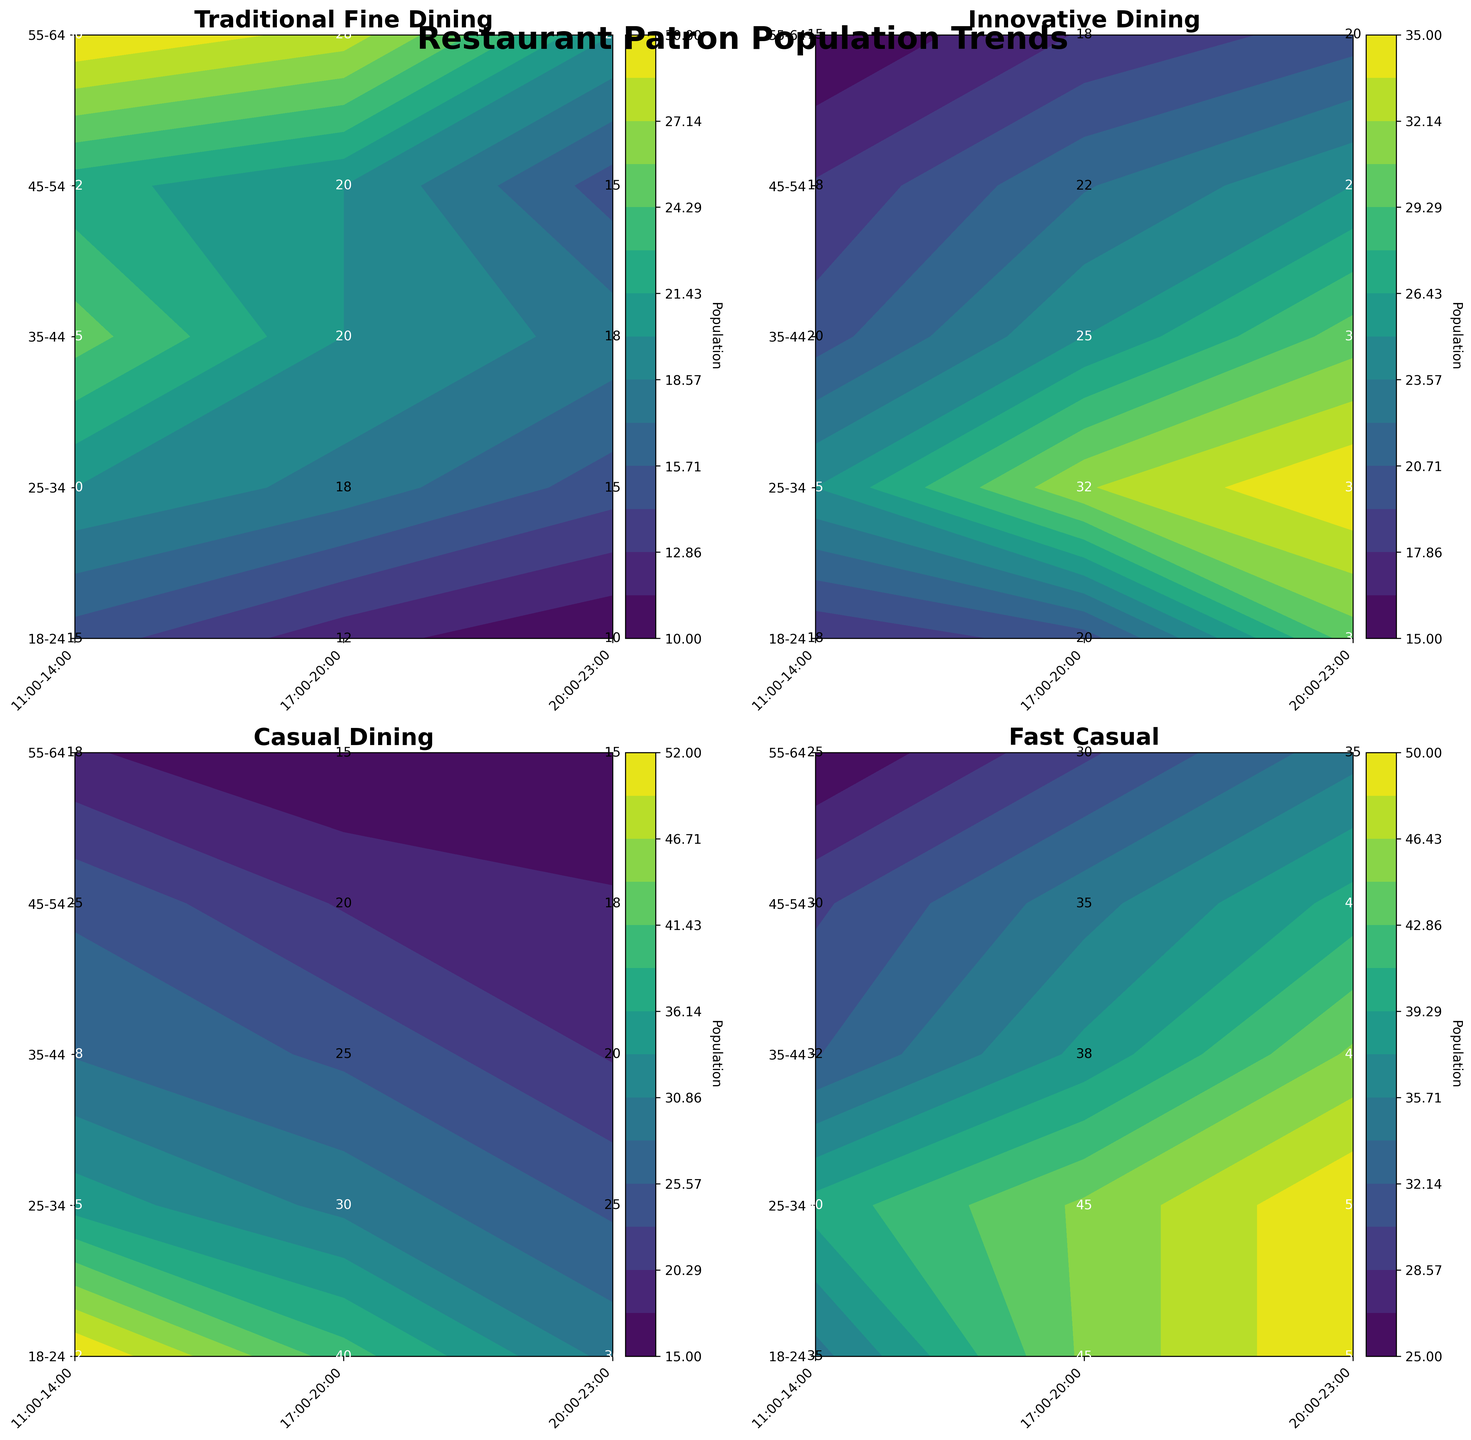What is the title of the figure? The title is displayed at the top of the figure and reads "Restaurant Patron Population Trends".
Answer: Restaurant Patron Population Trends How many subplots are in the figure? The figure is divided into a grid of 2 rows and 2 columns, with each subplot representing a different dining category.
Answer: 4 Which dining category has the highest population in the 18-24 age group during 20:00-23:00? In the subplot for Fast Casual, the 18-24 age group during 20:00-23:00 has the highest population with a value of 50.
Answer: Fast Casual What time slot sees the most patrons in the 55-64 age group for Traditional Fine Dining? In the Traditional Fine Dining subplot, the 11:00-14:00 time slot has the highest value for the 55-64 age group.
Answer: 11:00-14:00 In the Innovative Dining category, which age group has the lowest population during 17:00-20:00? By checking the subplot for Innovative Dining, the 55-64 age group has the lowest population during 17:00-20:00, with a value of 18.
Answer: 55-64 How does the population trend in Fast Casual dining change across age groups during 11:00-14:00? The color intensity increases gradually from the 18-24 age group to the 55-64 age group, indicating an upward trend in the population.
Answer: Increases Which dining category sees the least number of patrons overall, and during which time slot? From observing all subplots, the Casual Dining category during 20:00-23:00 time slot appears to have the lowest overall counts, especially for the 55-64 age group with a value of 15.
Answer: Casual Dining, 20:00-23:00 Comparing Traditional Fine Dining and Innovative Dining, which age group shows the most significant increase in population from 17:00-20:00 to 20:00-23:00? In the Traditional Fine Dining subplot, the change from 17:00-20:00 to 20:00-23:00 is minor. In Innovative Dining, the 18-24 age group shows an increase from 20 to 30. The difference is 10.
Answer: 18-24 in Innovative Dining What is the average population for the 25-34 age group in the Casual Dining category across all time slots? The values for the 25-34 age group in Casual Dining are 35, 30, and 25. The average is calculated as (35 + 30 + 25) / 3 = 90 / 3 = 30.
Answer: 30 